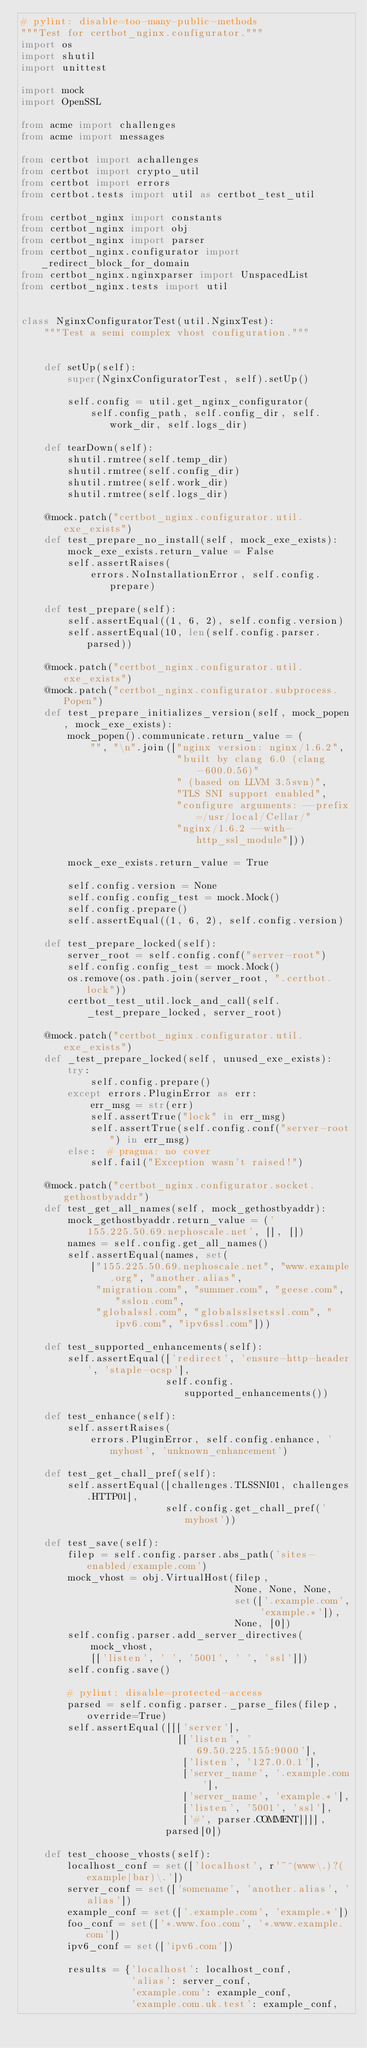<code> <loc_0><loc_0><loc_500><loc_500><_Python_># pylint: disable=too-many-public-methods
"""Test for certbot_nginx.configurator."""
import os
import shutil
import unittest

import mock
import OpenSSL

from acme import challenges
from acme import messages

from certbot import achallenges
from certbot import crypto_util
from certbot import errors
from certbot.tests import util as certbot_test_util

from certbot_nginx import constants
from certbot_nginx import obj
from certbot_nginx import parser
from certbot_nginx.configurator import _redirect_block_for_domain
from certbot_nginx.nginxparser import UnspacedList
from certbot_nginx.tests import util


class NginxConfiguratorTest(util.NginxTest):
    """Test a semi complex vhost configuration."""


    def setUp(self):
        super(NginxConfiguratorTest, self).setUp()

        self.config = util.get_nginx_configurator(
            self.config_path, self.config_dir, self.work_dir, self.logs_dir)

    def tearDown(self):
        shutil.rmtree(self.temp_dir)
        shutil.rmtree(self.config_dir)
        shutil.rmtree(self.work_dir)
        shutil.rmtree(self.logs_dir)

    @mock.patch("certbot_nginx.configurator.util.exe_exists")
    def test_prepare_no_install(self, mock_exe_exists):
        mock_exe_exists.return_value = False
        self.assertRaises(
            errors.NoInstallationError, self.config.prepare)

    def test_prepare(self):
        self.assertEqual((1, 6, 2), self.config.version)
        self.assertEqual(10, len(self.config.parser.parsed))

    @mock.patch("certbot_nginx.configurator.util.exe_exists")
    @mock.patch("certbot_nginx.configurator.subprocess.Popen")
    def test_prepare_initializes_version(self, mock_popen, mock_exe_exists):
        mock_popen().communicate.return_value = (
            "", "\n".join(["nginx version: nginx/1.6.2",
                           "built by clang 6.0 (clang-600.0.56)"
                           " (based on LLVM 3.5svn)",
                           "TLS SNI support enabled",
                           "configure arguments: --prefix=/usr/local/Cellar/"
                           "nginx/1.6.2 --with-http_ssl_module"]))

        mock_exe_exists.return_value = True

        self.config.version = None
        self.config.config_test = mock.Mock()
        self.config.prepare()
        self.assertEqual((1, 6, 2), self.config.version)

    def test_prepare_locked(self):
        server_root = self.config.conf("server-root")
        self.config.config_test = mock.Mock()
        os.remove(os.path.join(server_root, ".certbot.lock"))
        certbot_test_util.lock_and_call(self._test_prepare_locked, server_root)

    @mock.patch("certbot_nginx.configurator.util.exe_exists")
    def _test_prepare_locked(self, unused_exe_exists):
        try:
            self.config.prepare()
        except errors.PluginError as err:
            err_msg = str(err)
            self.assertTrue("lock" in err_msg)
            self.assertTrue(self.config.conf("server-root") in err_msg)
        else:  # pragma: no cover
            self.fail("Exception wasn't raised!")

    @mock.patch("certbot_nginx.configurator.socket.gethostbyaddr")
    def test_get_all_names(self, mock_gethostbyaddr):
        mock_gethostbyaddr.return_value = ('155.225.50.69.nephoscale.net', [], [])
        names = self.config.get_all_names()
        self.assertEqual(names, set(
            ["155.225.50.69.nephoscale.net", "www.example.org", "another.alias",
             "migration.com", "summer.com", "geese.com", "sslon.com",
             "globalssl.com", "globalsslsetssl.com", "ipv6.com", "ipv6ssl.com"]))

    def test_supported_enhancements(self):
        self.assertEqual(['redirect', 'ensure-http-header', 'staple-ocsp'],
                         self.config.supported_enhancements())

    def test_enhance(self):
        self.assertRaises(
            errors.PluginError, self.config.enhance, 'myhost', 'unknown_enhancement')

    def test_get_chall_pref(self):
        self.assertEqual([challenges.TLSSNI01, challenges.HTTP01],
                         self.config.get_chall_pref('myhost'))

    def test_save(self):
        filep = self.config.parser.abs_path('sites-enabled/example.com')
        mock_vhost = obj.VirtualHost(filep,
                                     None, None, None,
                                     set(['.example.com', 'example.*']),
                                     None, [0])
        self.config.parser.add_server_directives(
            mock_vhost,
            [['listen', ' ', '5001', ' ', 'ssl']])
        self.config.save()

        # pylint: disable=protected-access
        parsed = self.config.parser._parse_files(filep, override=True)
        self.assertEqual([[['server'],
                           [['listen', '69.50.225.155:9000'],
                            ['listen', '127.0.0.1'],
                            ['server_name', '.example.com'],
                            ['server_name', 'example.*'],
                            ['listen', '5001', 'ssl'],
                            ['#', parser.COMMENT]]]],
                         parsed[0])

    def test_choose_vhosts(self):
        localhost_conf = set(['localhost', r'~^(www\.)?(example|bar)\.'])
        server_conf = set(['somename', 'another.alias', 'alias'])
        example_conf = set(['.example.com', 'example.*'])
        foo_conf = set(['*.www.foo.com', '*.www.example.com'])
        ipv6_conf = set(['ipv6.com'])

        results = {'localhost': localhost_conf,
                   'alias': server_conf,
                   'example.com': example_conf,
                   'example.com.uk.test': example_conf,</code> 